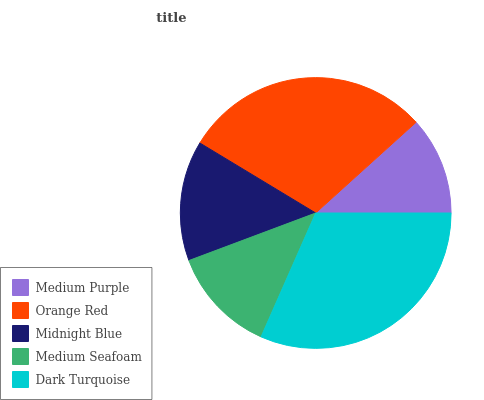Is Medium Purple the minimum?
Answer yes or no. Yes. Is Dark Turquoise the maximum?
Answer yes or no. Yes. Is Orange Red the minimum?
Answer yes or no. No. Is Orange Red the maximum?
Answer yes or no. No. Is Orange Red greater than Medium Purple?
Answer yes or no. Yes. Is Medium Purple less than Orange Red?
Answer yes or no. Yes. Is Medium Purple greater than Orange Red?
Answer yes or no. No. Is Orange Red less than Medium Purple?
Answer yes or no. No. Is Midnight Blue the high median?
Answer yes or no. Yes. Is Midnight Blue the low median?
Answer yes or no. Yes. Is Dark Turquoise the high median?
Answer yes or no. No. Is Medium Purple the low median?
Answer yes or no. No. 